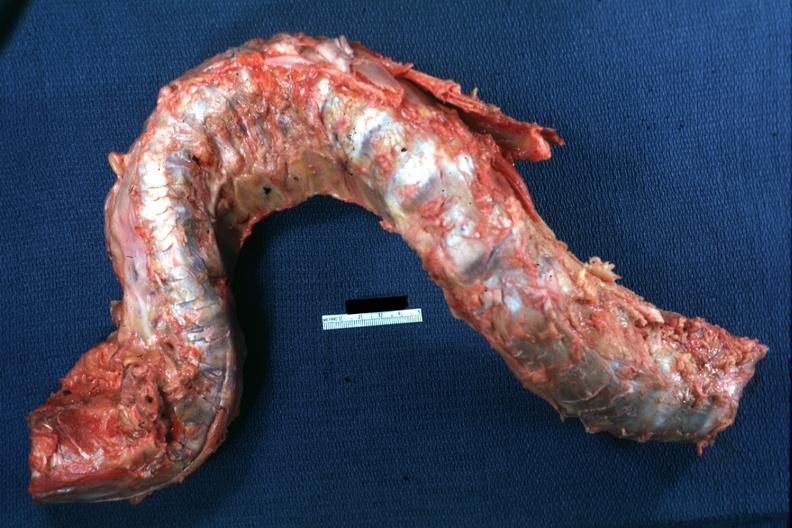s spinal column deformed?
Answer the question using a single word or phrase. Yes 